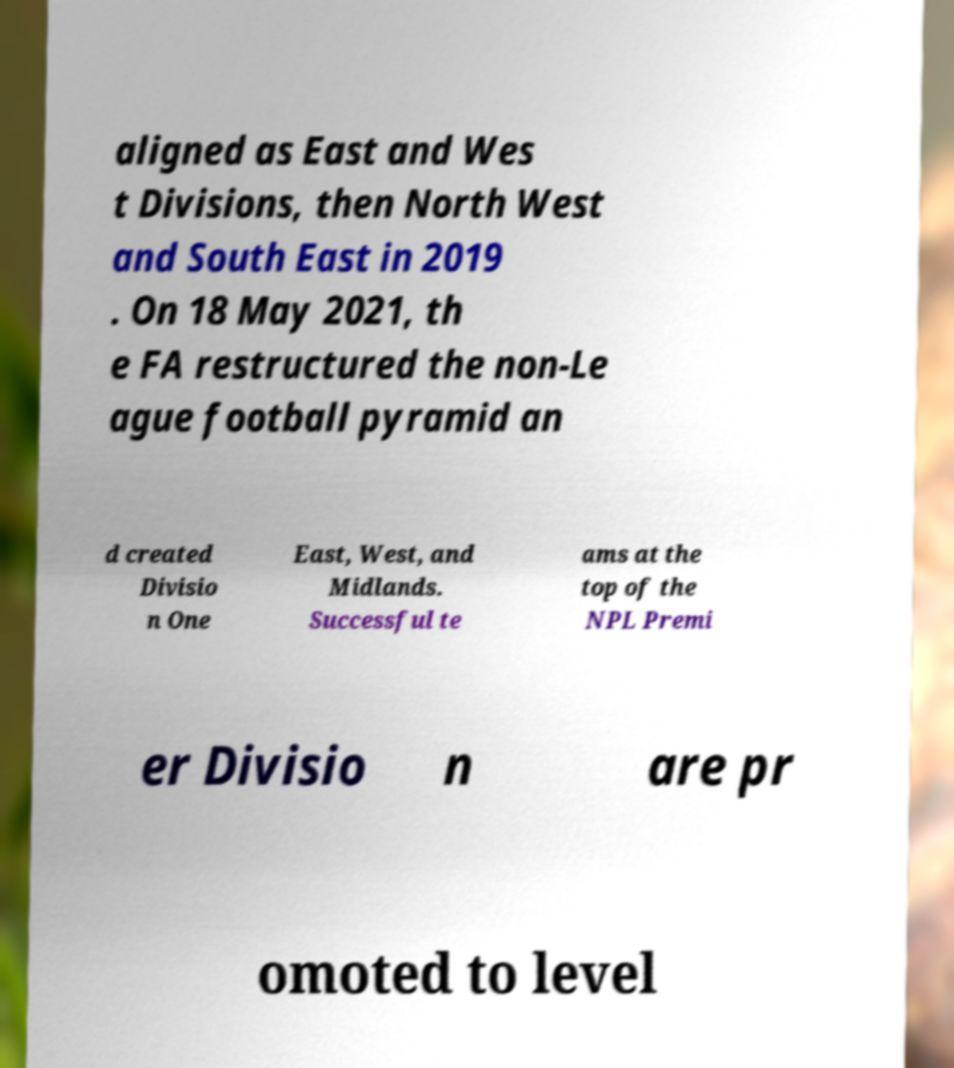For documentation purposes, I need the text within this image transcribed. Could you provide that? aligned as East and Wes t Divisions, then North West and South East in 2019 . On 18 May 2021, th e FA restructured the non-Le ague football pyramid an d created Divisio n One East, West, and Midlands. Successful te ams at the top of the NPL Premi er Divisio n are pr omoted to level 